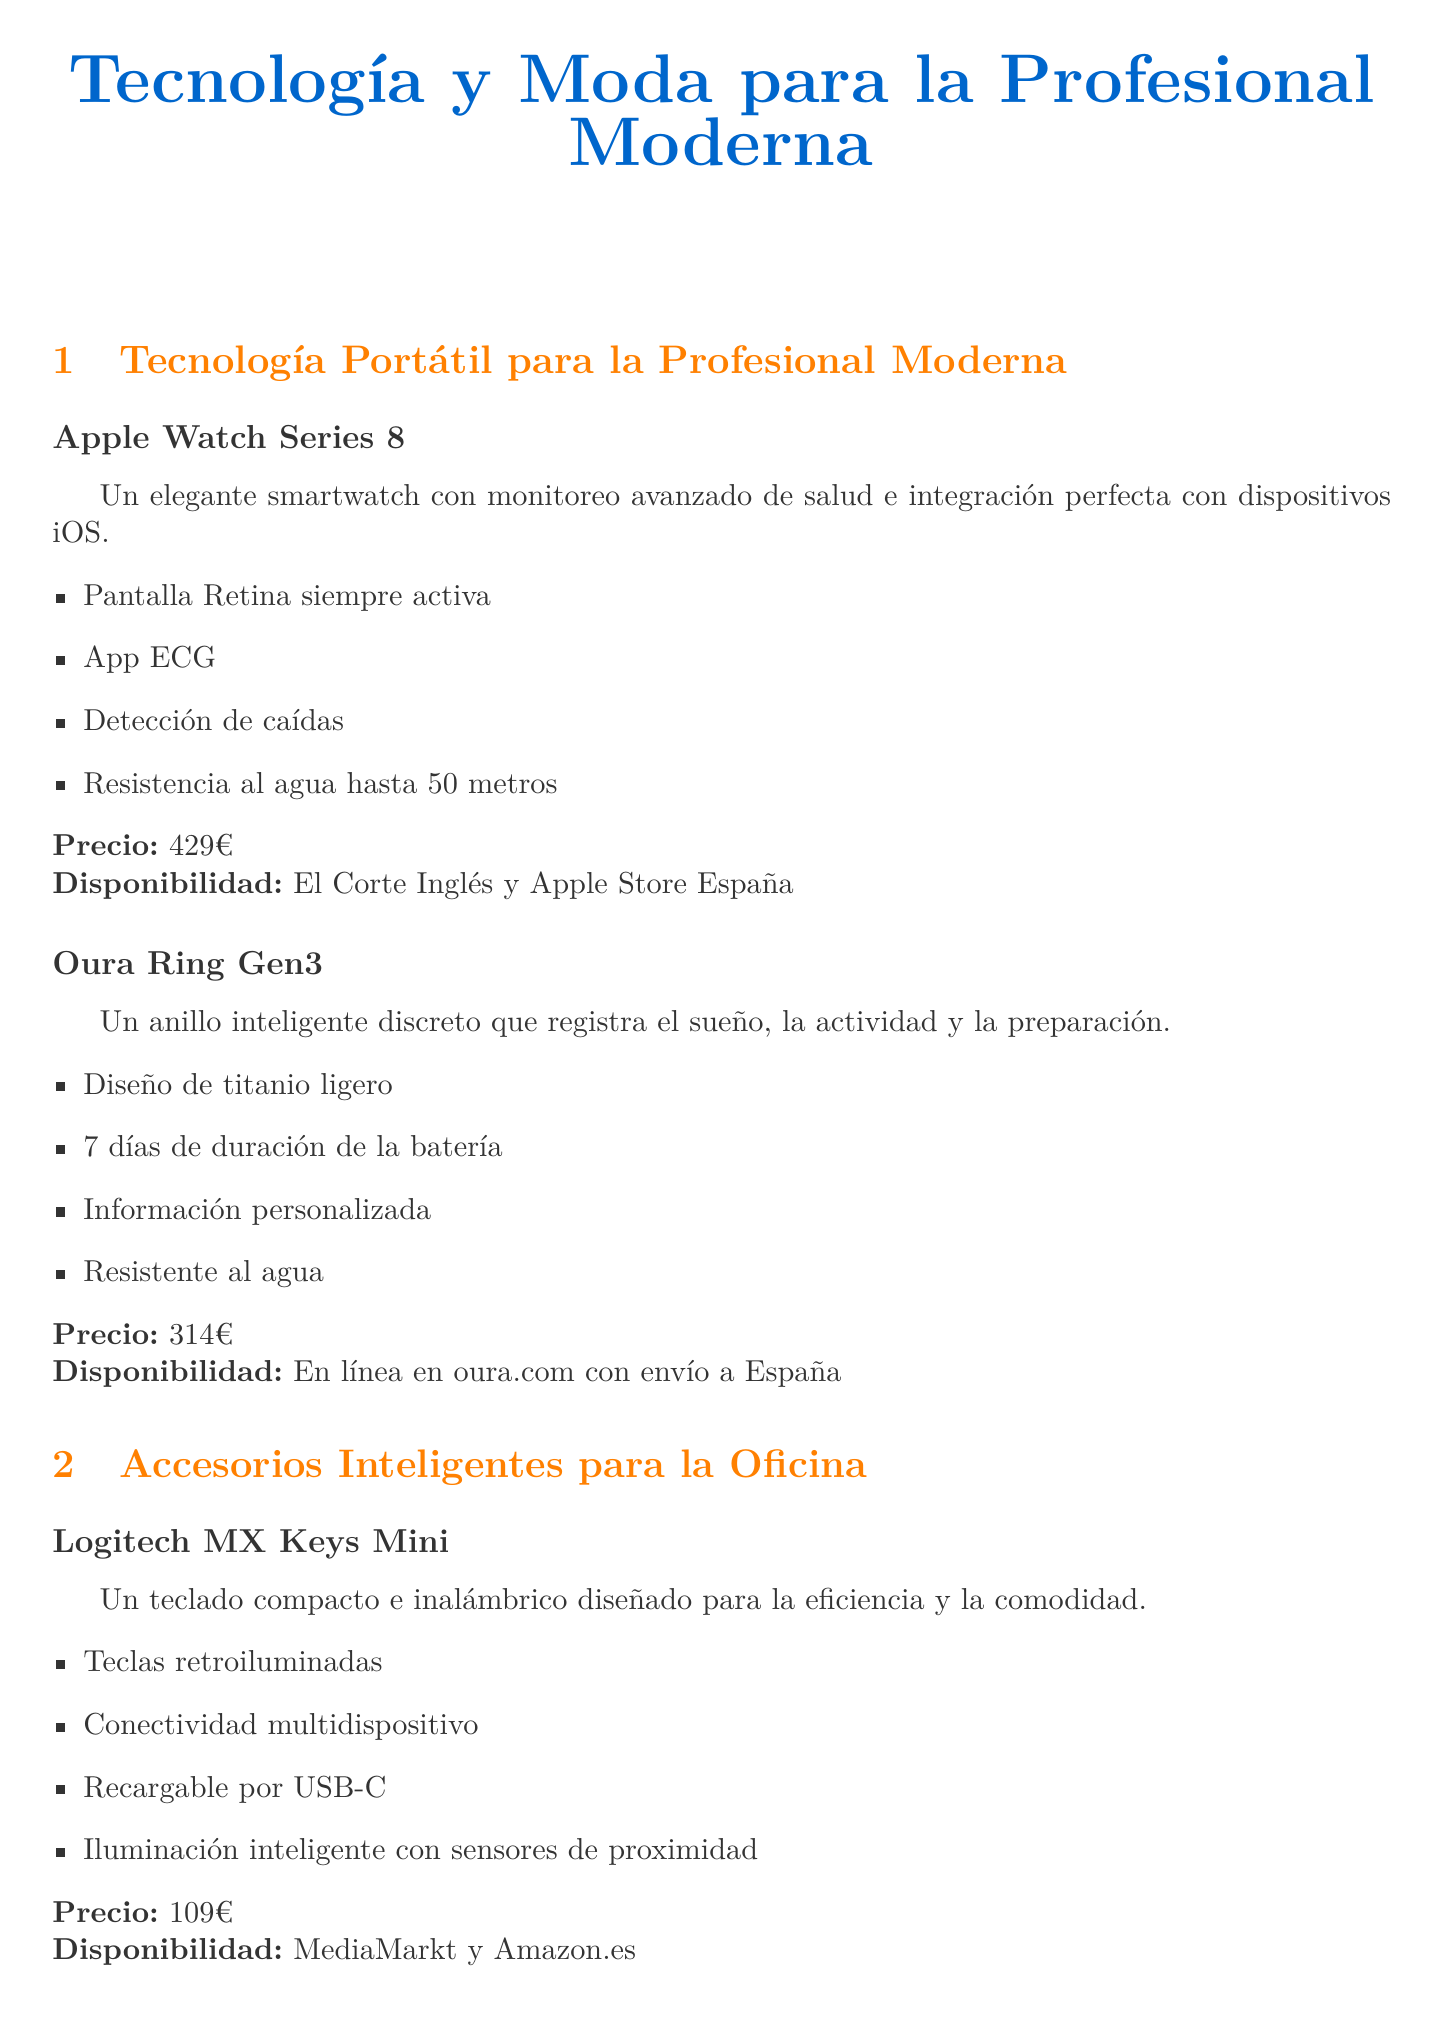¿Qué es el precio del Apple Watch Series 8? El precio del Apple Watch Series 8 está indicado en el documento como 429€.
Answer: 429€ ¿Cuáles son los productos disponibles en El Corte Inglés? En el documento se menciona que el Apple Watch Series 8 y los auriculares House of Marley Redemption ANC 2 están disponibles en El Corte Inglés.
Answer: Apple Watch Series 8, House of Marley Redemption ANC 2 ¿Cuánto dura la batería del Oura Ring Gen3? Se menciona que la duración de la batería del Oura Ring Gen3 es de 7 días.
Answer: 7 días ¿Qué características tiene el Logitech MX Keys Mini? Las características se extraen del documento, que enumera funciones como teclas retroiluminadas y conectividad multidispositivo.
Answer: Teclas retroiluminadas, conectividad multidispositivo ¿Qué producto tiene tecnología de cancelación de ruido? Se menciona que los Sony WH-1000XM5 cuentan con cancelación de ruido.
Answer: Sony WH-1000XM5 ¿Cuál es la disponibilidad de la Rothy's The Laptop Bag? La disponibilidad se refiere a que está disponible en línea en rothys.com con envío internacional.
Answer: En línea en rothys.com con envío internacional ¿Cómo se caracteriza el Ember Mug²? Se enfatiza que el Ember Mug² tiene control de temperatura y una duración de batería de 1.5 horas.
Answer: Control de temperatura, 1.5 horas ¿Qué material se utiliza en los auriculares House of Marley Redemption ANC 2? El documento menciona que están fabricados con bambú, silicona reciclada y plástico reciclado.
Answer: Bambú, silicona reciclada, plástico reciclado 